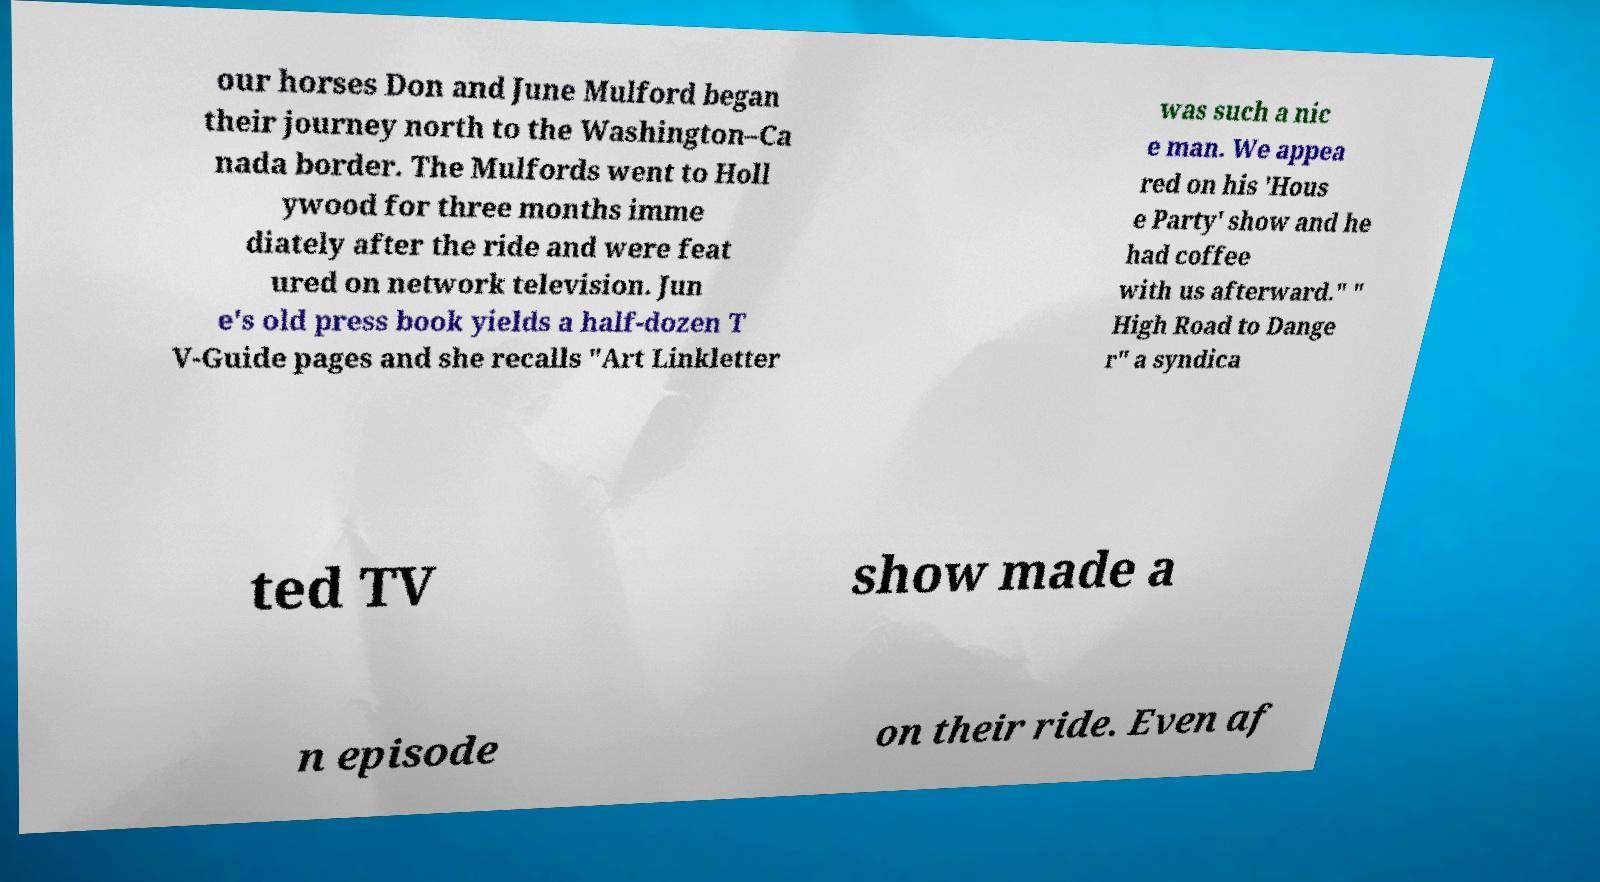Can you read and provide the text displayed in the image?This photo seems to have some interesting text. Can you extract and type it out for me? our horses Don and June Mulford began their journey north to the Washington–Ca nada border. The Mulfords went to Holl ywood for three months imme diately after the ride and were feat ured on network television. Jun e's old press book yields a half-dozen T V-Guide pages and she recalls "Art Linkletter was such a nic e man. We appea red on his 'Hous e Party' show and he had coffee with us afterward." " High Road to Dange r" a syndica ted TV show made a n episode on their ride. Even af 